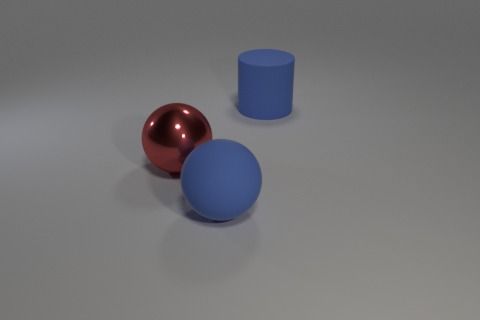Add 3 red cubes. How many objects exist? 6 Subtract 1 balls. How many balls are left? 1 Subtract all green blocks. How many red cylinders are left? 0 Subtract all balls. Subtract all big red spheres. How many objects are left? 0 Add 3 blue rubber spheres. How many blue rubber spheres are left? 4 Add 2 red metal objects. How many red metal objects exist? 3 Subtract 0 cyan balls. How many objects are left? 3 Subtract all spheres. How many objects are left? 1 Subtract all brown cylinders. Subtract all green cubes. How many cylinders are left? 1 